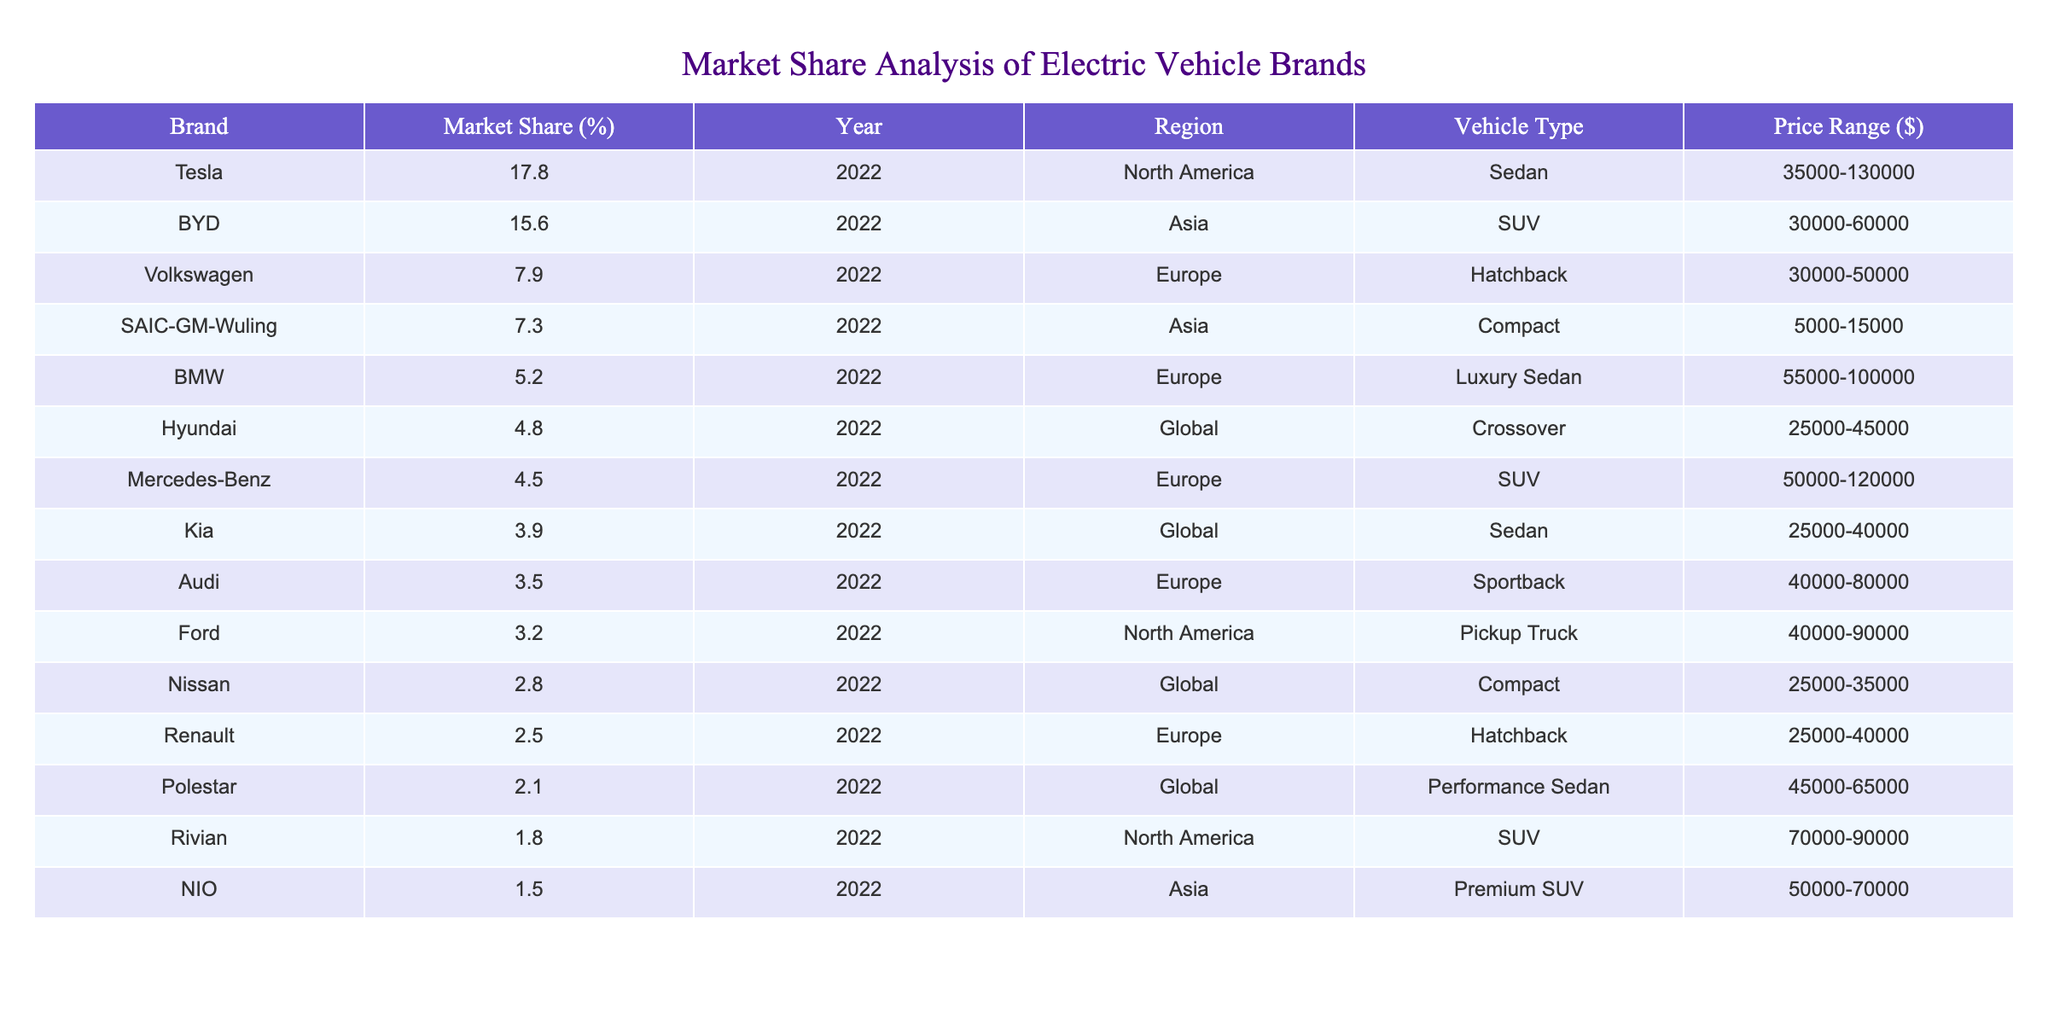What is the market share percentage of Tesla in 2022? In the table, Tesla is listed with a market share of 17.8% for the year 2022.
Answer: 17.8% Which brand has the highest market share in Asia? According to the table, BYD has the highest market share in Asia at 15.6% for the year 2022.
Answer: BYD How many brands have a market share greater than 5%? Upon examining the table, there are 6 brands (Tesla, BYD, Volkswagen, SAIC-GM-Wuling, BMW, and Hyundai) with a market share greater than 5%.
Answer: 6 What is the average market share of European brands listed in the table? The market shares for European brands are: Volkswagen (7.9%), BMW (5.2%), Mercedes-Benz (4.5%), and Renault (2.5%). Adding these values gives a total of 20.1%. Dividing by the number of brands (4) gives an average of 20.1% / 4 = 5.025%.
Answer: 5.025% Does any brand have a market share less than 2%? Reviewing the table, none of the listed brands have a market share below 2% as the lowest market share is 1.5% for NIO.
Answer: No What is the total market share of brands in North America? The brands in North America are Tesla (17.8%) and Ford (3.2%). Adding their market shares gives a total of 17.8% + 3.2% = 21%.
Answer: 21% Which brand is the cheapest among the electric vehicle brands listed? From the table, SAIC-GM-Wuling has the lowest price range at $5,000-$15,000, making it the cheapest brand.
Answer: SAIC-GM-Wuling What percentage of the overall market share do Tesla and BYD hold combined? Tesla has 17.8% and BYD has 15.6%, combining these gives 17.8% + 15.6% = 33.4% market share jointly held by both brands.
Answer: 33.4% Is Hyundai considered a luxury brand based on the table? Hyundai is listed under the category of Crossover vehicles and does not appear among luxury brands like BMW or Mercedes-Benz in the table.
Answer: No Which region has the lowest market share represented by a single brand? In Asia, SAIC-GM-Wuling has the lowest market share of 7.3% compared to the other brands in different regions.
Answer: Asia What is the market share difference between Volkswagen and Kia? Volkswagen has a market share of 7.9% while Kia has 3.9%. The difference is calculated as 7.9% - 3.9% = 4%.
Answer: 4% 